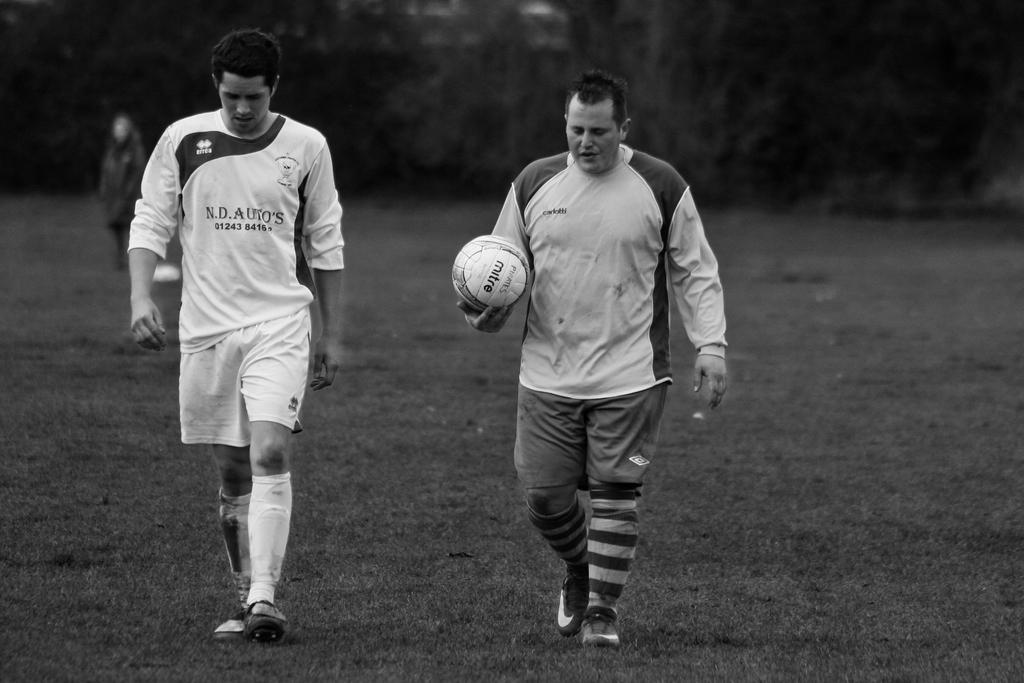What is the man in the image holding? The man is holding a football. Can you describe the other person in the image? There is another person walking in the image, and they are beside the man holding the football. Where does the scene take place? The scene takes place on a grass field. What might the two people be doing in the image? They might be playing or practicing football, given that one person is holding a football and the other is walking nearby. Where is the cellar located in the image? There is no cellar present in the image. What type of toys can be seen in the hands of the walking person? There are no toys visible in the image; the walking person is not holding anything. 